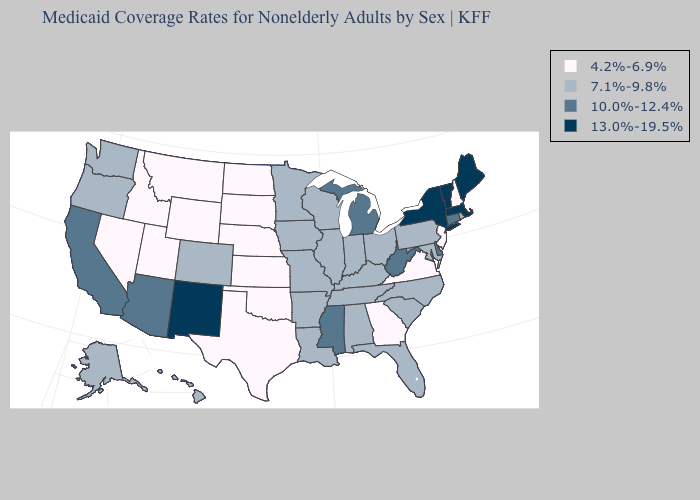Name the states that have a value in the range 4.2%-6.9%?
Answer briefly. Georgia, Idaho, Kansas, Montana, Nebraska, Nevada, New Hampshire, New Jersey, North Dakota, Oklahoma, South Dakota, Texas, Utah, Virginia, Wyoming. Does Minnesota have the highest value in the MidWest?
Be succinct. No. Does the map have missing data?
Short answer required. No. Name the states that have a value in the range 10.0%-12.4%?
Concise answer only. Arizona, California, Connecticut, Delaware, Michigan, Mississippi, West Virginia. What is the value of New Mexico?
Concise answer only. 13.0%-19.5%. Name the states that have a value in the range 4.2%-6.9%?
Write a very short answer. Georgia, Idaho, Kansas, Montana, Nebraska, Nevada, New Hampshire, New Jersey, North Dakota, Oklahoma, South Dakota, Texas, Utah, Virginia, Wyoming. What is the highest value in the USA?
Answer briefly. 13.0%-19.5%. What is the lowest value in the South?
Concise answer only. 4.2%-6.9%. Name the states that have a value in the range 13.0%-19.5%?
Keep it brief. Maine, Massachusetts, New Mexico, New York, Vermont. Does the first symbol in the legend represent the smallest category?
Quick response, please. Yes. What is the value of Texas?
Give a very brief answer. 4.2%-6.9%. Does Minnesota have a higher value than Montana?
Short answer required. Yes. What is the value of California?
Keep it brief. 10.0%-12.4%. What is the highest value in the West ?
Be succinct. 13.0%-19.5%. What is the value of New Hampshire?
Be succinct. 4.2%-6.9%. 